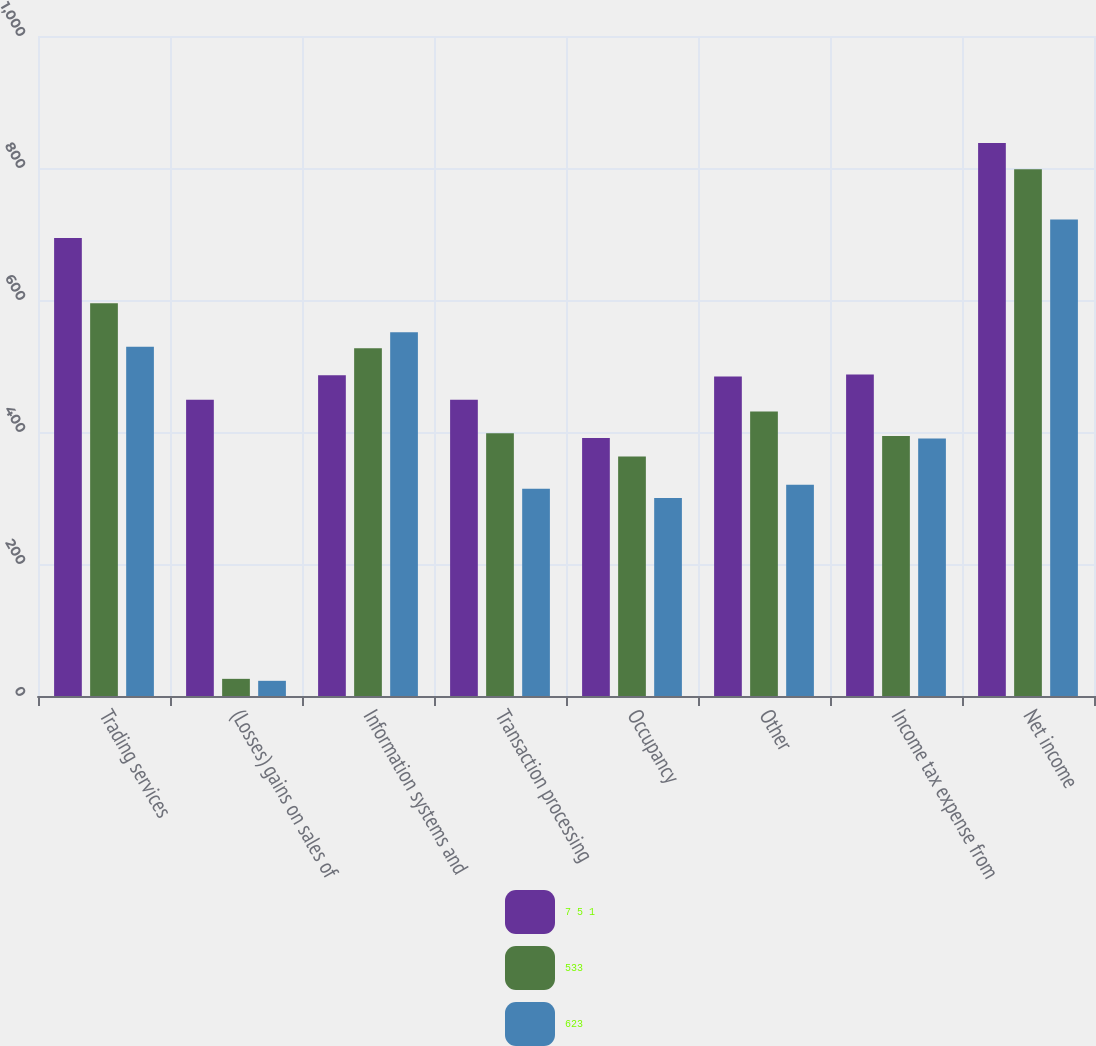Convert chart. <chart><loc_0><loc_0><loc_500><loc_500><stacked_bar_chart><ecel><fcel>Trading services<fcel>(Losses) gains on sales of<fcel>Information systems and<fcel>Transaction processing<fcel>Occupancy<fcel>Other<fcel>Income tax expense from<fcel>Net income<nl><fcel>7 5 1<fcel>694<fcel>449<fcel>486<fcel>449<fcel>391<fcel>484<fcel>487<fcel>838<nl><fcel>533<fcel>595<fcel>26<fcel>527<fcel>398<fcel>363<fcel>431<fcel>394<fcel>798<nl><fcel>623<fcel>529<fcel>23<fcel>551<fcel>314<fcel>300<fcel>320<fcel>390<fcel>722<nl></chart> 